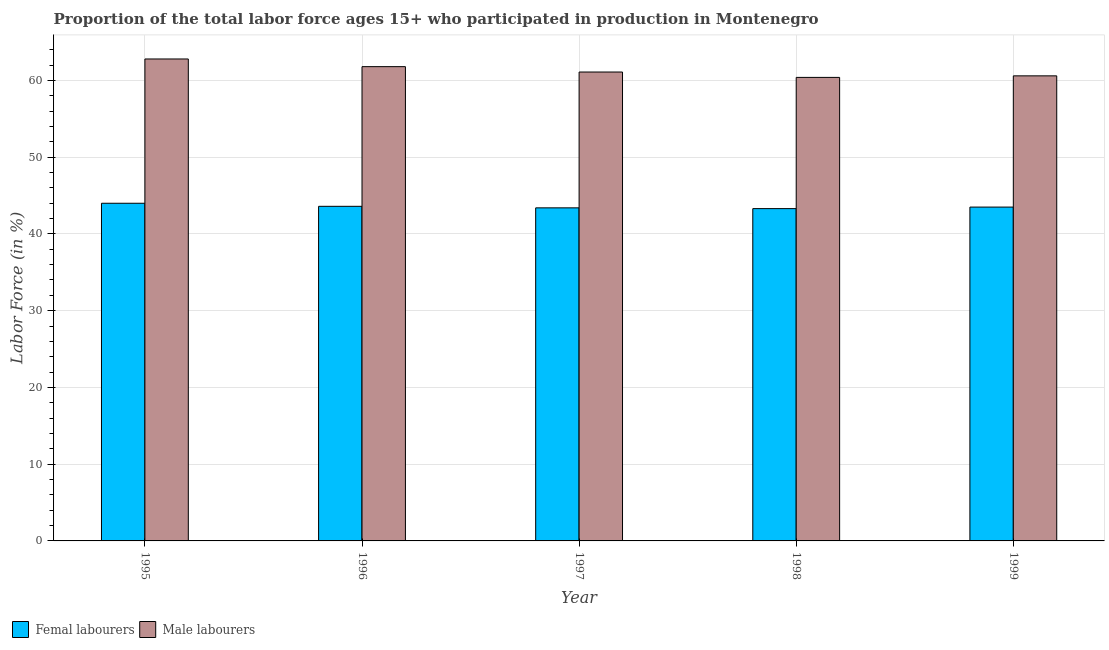How many different coloured bars are there?
Provide a short and direct response. 2. How many groups of bars are there?
Keep it short and to the point. 5. Are the number of bars on each tick of the X-axis equal?
Your answer should be very brief. Yes. What is the label of the 1st group of bars from the left?
Offer a very short reply. 1995. In how many cases, is the number of bars for a given year not equal to the number of legend labels?
Offer a very short reply. 0. What is the percentage of female labor force in 1998?
Provide a short and direct response. 43.3. Across all years, what is the maximum percentage of male labour force?
Provide a short and direct response. 62.8. Across all years, what is the minimum percentage of female labor force?
Give a very brief answer. 43.3. In which year was the percentage of male labour force maximum?
Your answer should be compact. 1995. In which year was the percentage of male labour force minimum?
Your response must be concise. 1998. What is the total percentage of female labor force in the graph?
Your answer should be compact. 217.8. What is the difference between the percentage of male labour force in 1996 and that in 1999?
Your response must be concise. 1.2. What is the difference between the percentage of female labor force in 1995 and the percentage of male labour force in 1998?
Your response must be concise. 0.7. What is the average percentage of female labor force per year?
Keep it short and to the point. 43.56. What is the ratio of the percentage of male labour force in 1995 to that in 1998?
Provide a succinct answer. 1.04. What is the difference between the highest and the lowest percentage of male labour force?
Make the answer very short. 2.4. What does the 1st bar from the left in 1997 represents?
Your response must be concise. Femal labourers. What does the 1st bar from the right in 1999 represents?
Ensure brevity in your answer.  Male labourers. How many bars are there?
Ensure brevity in your answer.  10. How many years are there in the graph?
Make the answer very short. 5. What is the difference between two consecutive major ticks on the Y-axis?
Ensure brevity in your answer.  10. Are the values on the major ticks of Y-axis written in scientific E-notation?
Your answer should be very brief. No. Does the graph contain any zero values?
Your answer should be compact. No. What is the title of the graph?
Offer a very short reply. Proportion of the total labor force ages 15+ who participated in production in Montenegro. Does "RDB concessional" appear as one of the legend labels in the graph?
Provide a succinct answer. No. What is the label or title of the X-axis?
Your answer should be very brief. Year. What is the Labor Force (in %) of Male labourers in 1995?
Provide a succinct answer. 62.8. What is the Labor Force (in %) in Femal labourers in 1996?
Offer a terse response. 43.6. What is the Labor Force (in %) of Male labourers in 1996?
Your answer should be very brief. 61.8. What is the Labor Force (in %) of Femal labourers in 1997?
Keep it short and to the point. 43.4. What is the Labor Force (in %) of Male labourers in 1997?
Your answer should be compact. 61.1. What is the Labor Force (in %) of Femal labourers in 1998?
Provide a short and direct response. 43.3. What is the Labor Force (in %) of Male labourers in 1998?
Your answer should be very brief. 60.4. What is the Labor Force (in %) of Femal labourers in 1999?
Make the answer very short. 43.5. What is the Labor Force (in %) of Male labourers in 1999?
Provide a succinct answer. 60.6. Across all years, what is the maximum Labor Force (in %) of Femal labourers?
Your response must be concise. 44. Across all years, what is the maximum Labor Force (in %) in Male labourers?
Give a very brief answer. 62.8. Across all years, what is the minimum Labor Force (in %) of Femal labourers?
Give a very brief answer. 43.3. Across all years, what is the minimum Labor Force (in %) of Male labourers?
Offer a very short reply. 60.4. What is the total Labor Force (in %) in Femal labourers in the graph?
Provide a short and direct response. 217.8. What is the total Labor Force (in %) in Male labourers in the graph?
Offer a terse response. 306.7. What is the difference between the Labor Force (in %) in Femal labourers in 1995 and that in 1996?
Your answer should be compact. 0.4. What is the difference between the Labor Force (in %) of Male labourers in 1995 and that in 1996?
Keep it short and to the point. 1. What is the difference between the Labor Force (in %) of Male labourers in 1995 and that in 1997?
Offer a very short reply. 1.7. What is the difference between the Labor Force (in %) in Femal labourers in 1995 and that in 1998?
Give a very brief answer. 0.7. What is the difference between the Labor Force (in %) in Male labourers in 1995 and that in 1999?
Ensure brevity in your answer.  2.2. What is the difference between the Labor Force (in %) in Femal labourers in 1996 and that in 1997?
Give a very brief answer. 0.2. What is the difference between the Labor Force (in %) in Male labourers in 1996 and that in 1998?
Make the answer very short. 1.4. What is the difference between the Labor Force (in %) of Femal labourers in 1996 and that in 1999?
Your answer should be very brief. 0.1. What is the difference between the Labor Force (in %) in Femal labourers in 1998 and that in 1999?
Ensure brevity in your answer.  -0.2. What is the difference between the Labor Force (in %) of Femal labourers in 1995 and the Labor Force (in %) of Male labourers in 1996?
Provide a short and direct response. -17.8. What is the difference between the Labor Force (in %) of Femal labourers in 1995 and the Labor Force (in %) of Male labourers in 1997?
Keep it short and to the point. -17.1. What is the difference between the Labor Force (in %) of Femal labourers in 1995 and the Labor Force (in %) of Male labourers in 1998?
Make the answer very short. -16.4. What is the difference between the Labor Force (in %) in Femal labourers in 1995 and the Labor Force (in %) in Male labourers in 1999?
Provide a succinct answer. -16.6. What is the difference between the Labor Force (in %) in Femal labourers in 1996 and the Labor Force (in %) in Male labourers in 1997?
Your answer should be very brief. -17.5. What is the difference between the Labor Force (in %) of Femal labourers in 1996 and the Labor Force (in %) of Male labourers in 1998?
Offer a very short reply. -16.8. What is the difference between the Labor Force (in %) of Femal labourers in 1996 and the Labor Force (in %) of Male labourers in 1999?
Make the answer very short. -17. What is the difference between the Labor Force (in %) in Femal labourers in 1997 and the Labor Force (in %) in Male labourers in 1998?
Keep it short and to the point. -17. What is the difference between the Labor Force (in %) of Femal labourers in 1997 and the Labor Force (in %) of Male labourers in 1999?
Your response must be concise. -17.2. What is the difference between the Labor Force (in %) in Femal labourers in 1998 and the Labor Force (in %) in Male labourers in 1999?
Offer a very short reply. -17.3. What is the average Labor Force (in %) in Femal labourers per year?
Offer a very short reply. 43.56. What is the average Labor Force (in %) in Male labourers per year?
Provide a succinct answer. 61.34. In the year 1995, what is the difference between the Labor Force (in %) of Femal labourers and Labor Force (in %) of Male labourers?
Your answer should be very brief. -18.8. In the year 1996, what is the difference between the Labor Force (in %) of Femal labourers and Labor Force (in %) of Male labourers?
Give a very brief answer. -18.2. In the year 1997, what is the difference between the Labor Force (in %) in Femal labourers and Labor Force (in %) in Male labourers?
Offer a very short reply. -17.7. In the year 1998, what is the difference between the Labor Force (in %) of Femal labourers and Labor Force (in %) of Male labourers?
Provide a succinct answer. -17.1. In the year 1999, what is the difference between the Labor Force (in %) of Femal labourers and Labor Force (in %) of Male labourers?
Offer a terse response. -17.1. What is the ratio of the Labor Force (in %) of Femal labourers in 1995 to that in 1996?
Your answer should be compact. 1.01. What is the ratio of the Labor Force (in %) of Male labourers in 1995 to that in 1996?
Give a very brief answer. 1.02. What is the ratio of the Labor Force (in %) in Femal labourers in 1995 to that in 1997?
Provide a short and direct response. 1.01. What is the ratio of the Labor Force (in %) in Male labourers in 1995 to that in 1997?
Keep it short and to the point. 1.03. What is the ratio of the Labor Force (in %) in Femal labourers in 1995 to that in 1998?
Your response must be concise. 1.02. What is the ratio of the Labor Force (in %) in Male labourers in 1995 to that in 1998?
Ensure brevity in your answer.  1.04. What is the ratio of the Labor Force (in %) in Femal labourers in 1995 to that in 1999?
Offer a terse response. 1.01. What is the ratio of the Labor Force (in %) in Male labourers in 1995 to that in 1999?
Provide a succinct answer. 1.04. What is the ratio of the Labor Force (in %) in Femal labourers in 1996 to that in 1997?
Give a very brief answer. 1. What is the ratio of the Labor Force (in %) of Male labourers in 1996 to that in 1997?
Ensure brevity in your answer.  1.01. What is the ratio of the Labor Force (in %) of Femal labourers in 1996 to that in 1998?
Your answer should be very brief. 1.01. What is the ratio of the Labor Force (in %) in Male labourers in 1996 to that in 1998?
Your answer should be very brief. 1.02. What is the ratio of the Labor Force (in %) in Femal labourers in 1996 to that in 1999?
Ensure brevity in your answer.  1. What is the ratio of the Labor Force (in %) of Male labourers in 1996 to that in 1999?
Ensure brevity in your answer.  1.02. What is the ratio of the Labor Force (in %) of Femal labourers in 1997 to that in 1998?
Your response must be concise. 1. What is the ratio of the Labor Force (in %) of Male labourers in 1997 to that in 1998?
Your response must be concise. 1.01. What is the ratio of the Labor Force (in %) in Male labourers in 1997 to that in 1999?
Your answer should be very brief. 1.01. What is the ratio of the Labor Force (in %) of Femal labourers in 1998 to that in 1999?
Make the answer very short. 1. What is the difference between the highest and the lowest Labor Force (in %) of Femal labourers?
Offer a terse response. 0.7. What is the difference between the highest and the lowest Labor Force (in %) of Male labourers?
Provide a succinct answer. 2.4. 